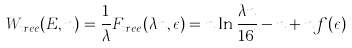Convert formula to latex. <formula><loc_0><loc_0><loc_500><loc_500>W _ { t r e e } ( E , n ) = \frac { 1 } { \lambda } F _ { t r e e } ( \lambda n , \epsilon ) = n \ln \frac { \lambda n } { 1 6 } - n + n f ( \epsilon )</formula> 